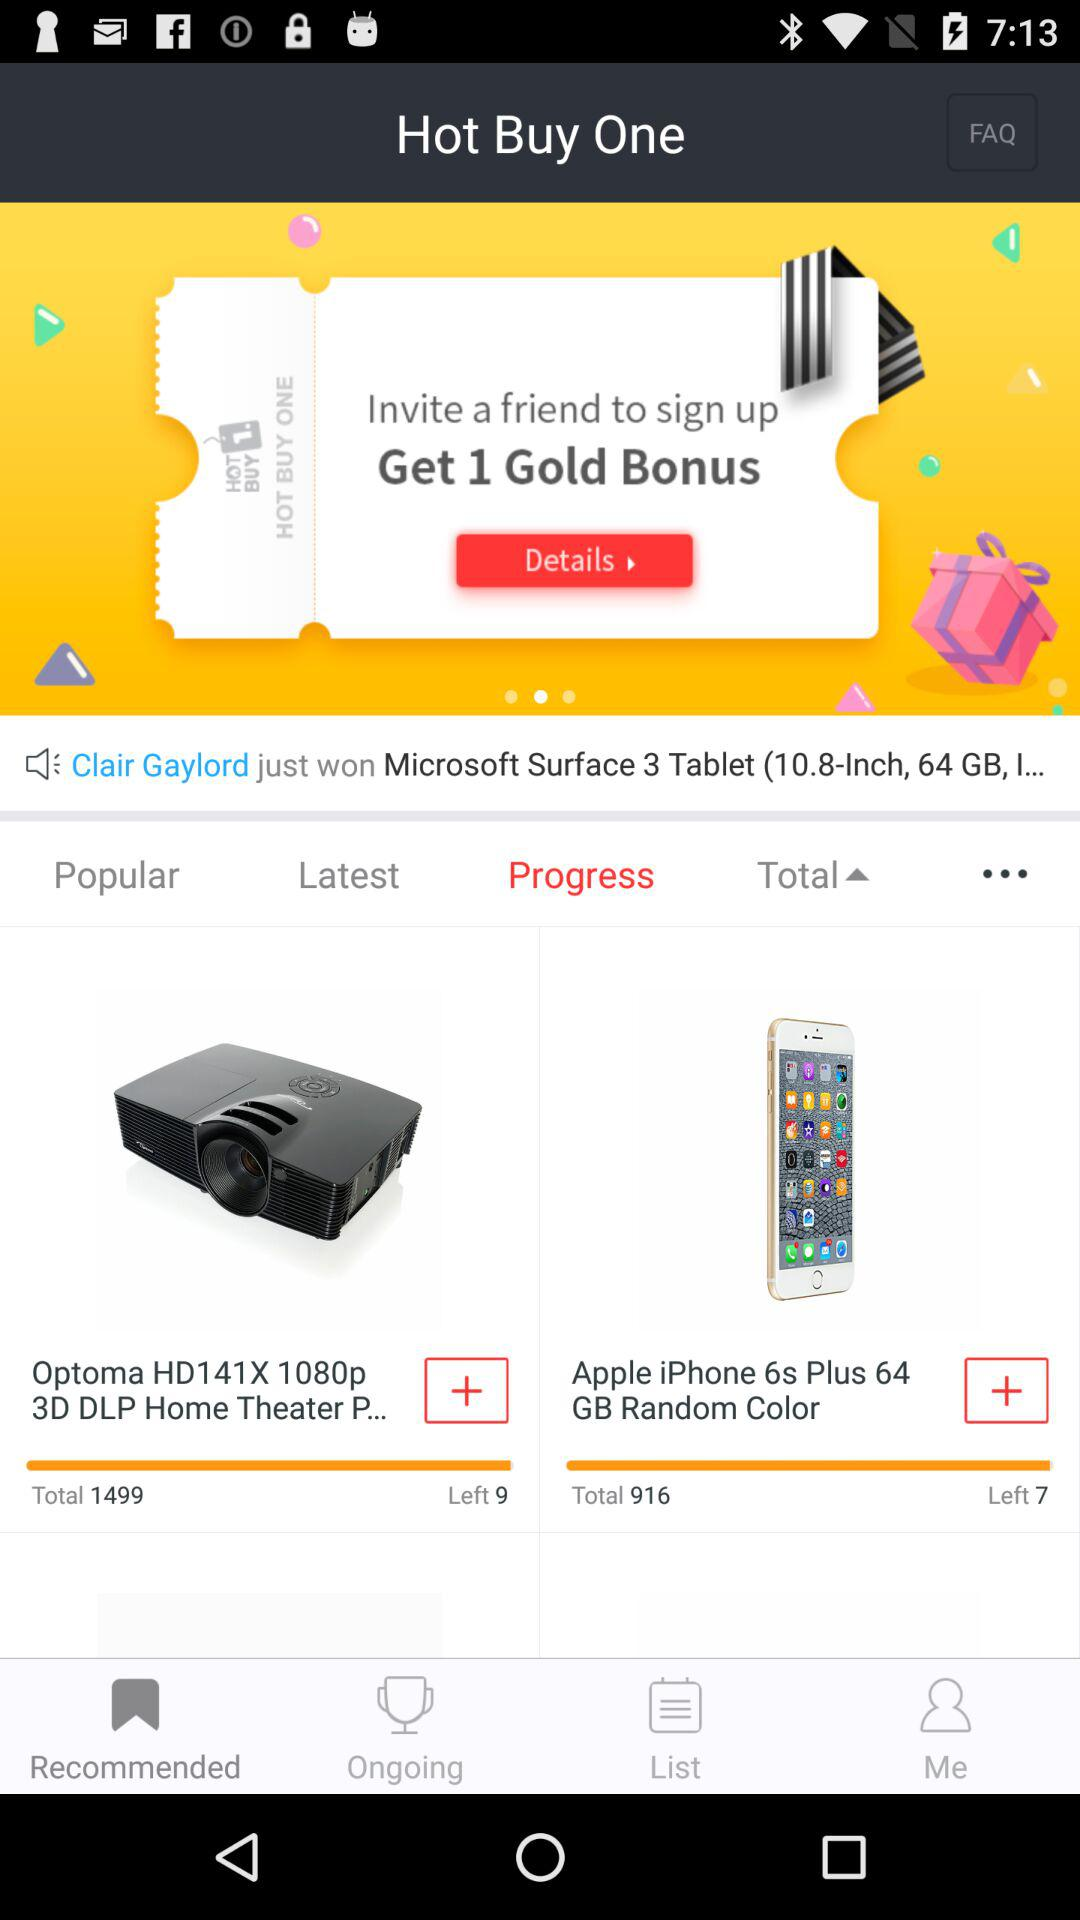How many "Apple iPhone 6s" in total are there? There are 916 "Apple iPhone 6s". 